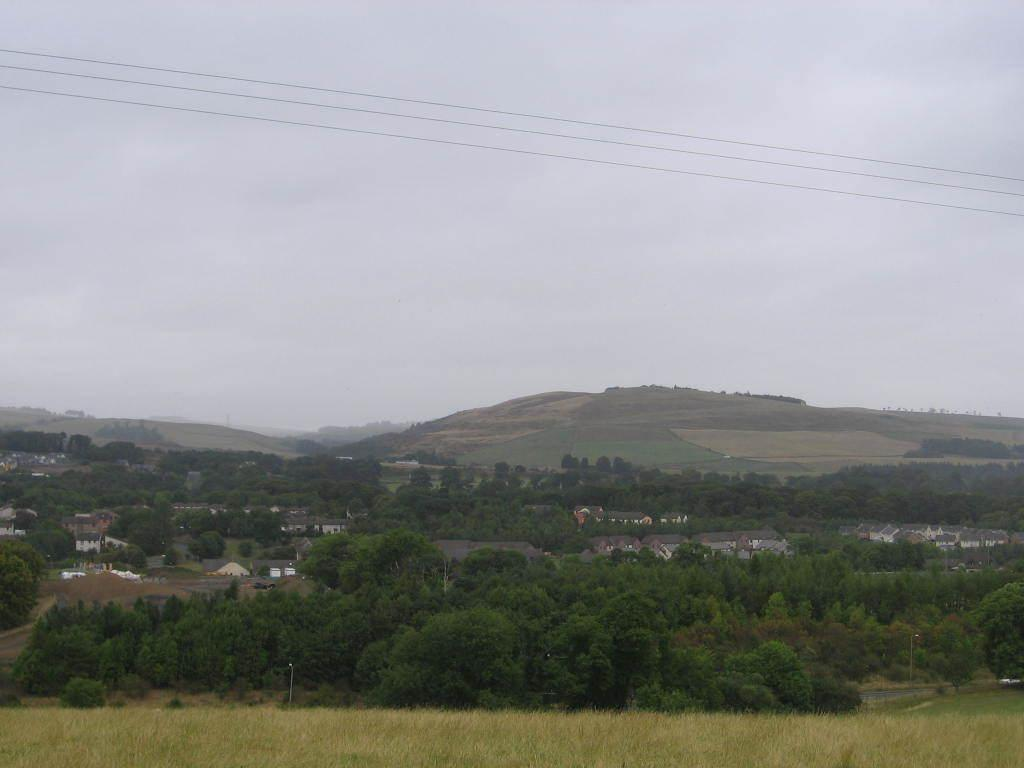What type of vegetation can be seen in the image? There are trees in the image. What type of structures are visible in the image? There are houses in the image. What is visible at the top of the image? The sky is visible at the top of the image, and clouds are visible in the sky. What is present at the bottom of the image? Grass is present at the bottom of the image. What else can be seen at the top of the image besides the sky? Wires are present at the top of the image. Can you tell me how many clams are depicted in the image? There are no clams present in the image; it features trees, houses, sky, clouds, wires, and grass. What type of art is displayed on the trees in the image? There is no art displayed on the trees in the image; the trees are natural vegetation. 